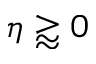Convert formula to latex. <formula><loc_0><loc_0><loc_500><loc_500>\eta \gtrapprox 0</formula> 